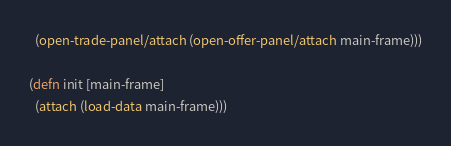Convert code to text. <code><loc_0><loc_0><loc_500><loc_500><_Clojure_>  (open-trade-panel/attach (open-offer-panel/attach main-frame)))

(defn init [main-frame]
  (attach (load-data main-frame)))</code> 